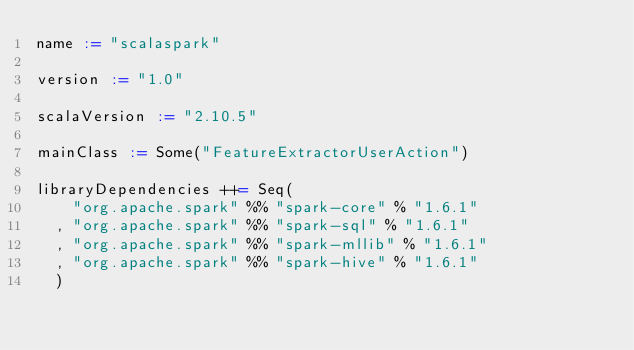<code> <loc_0><loc_0><loc_500><loc_500><_Scala_>name := "scalaspark"

version := "1.0"

scalaVersion := "2.10.5"

mainClass := Some("FeatureExtractorUserAction")

libraryDependencies ++= Seq(
    "org.apache.spark" %% "spark-core" % "1.6.1"
  , "org.apache.spark" %% "spark-sql" % "1.6.1"
  , "org.apache.spark" %% "spark-mllib" % "1.6.1"
  , "org.apache.spark" %% "spark-hive" % "1.6.1"
  )
</code> 